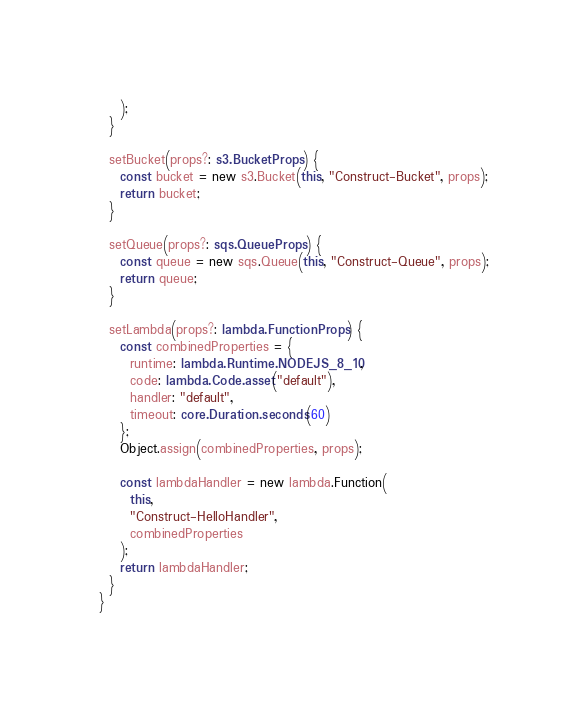Convert code to text. <code><loc_0><loc_0><loc_500><loc_500><_TypeScript_>    );
  }

  setBucket(props?: s3.BucketProps) {
    const bucket = new s3.Bucket(this, "Construct-Bucket", props);
    return bucket;
  }

  setQueue(props?: sqs.QueueProps) {
    const queue = new sqs.Queue(this, "Construct-Queue", props);
    return queue;
  }

  setLambda(props?: lambda.FunctionProps) {
    const combinedProperties = {
      runtime: lambda.Runtime.NODEJS_8_10,
      code: lambda.Code.asset("default"),
      handler: "default",
      timeout: core.Duration.seconds(60)
    };
    Object.assign(combinedProperties, props);

    const lambdaHandler = new lambda.Function(
      this,
      "Construct-HelloHandler",
      combinedProperties
    );
    return lambdaHandler;
  }
}
</code> 